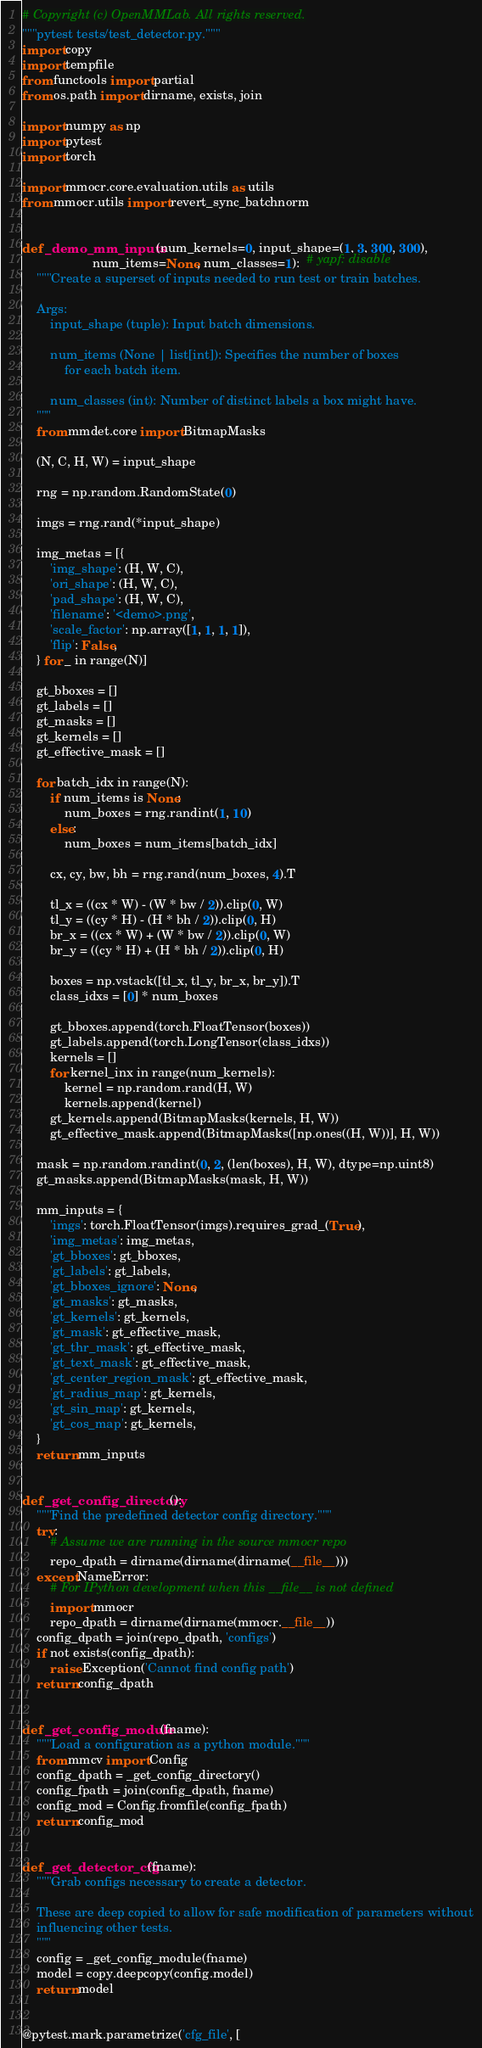Convert code to text. <code><loc_0><loc_0><loc_500><loc_500><_Python_># Copyright (c) OpenMMLab. All rights reserved.
"""pytest tests/test_detector.py."""
import copy
import tempfile
from functools import partial
from os.path import dirname, exists, join

import numpy as np
import pytest
import torch

import mmocr.core.evaluation.utils as utils
from mmocr.utils import revert_sync_batchnorm


def _demo_mm_inputs(num_kernels=0, input_shape=(1, 3, 300, 300),
                    num_items=None, num_classes=1):  # yapf: disable
    """Create a superset of inputs needed to run test or train batches.

    Args:
        input_shape (tuple): Input batch dimensions.

        num_items (None | list[int]): Specifies the number of boxes
            for each batch item.

        num_classes (int): Number of distinct labels a box might have.
    """
    from mmdet.core import BitmapMasks

    (N, C, H, W) = input_shape

    rng = np.random.RandomState(0)

    imgs = rng.rand(*input_shape)

    img_metas = [{
        'img_shape': (H, W, C),
        'ori_shape': (H, W, C),
        'pad_shape': (H, W, C),
        'filename': '<demo>.png',
        'scale_factor': np.array([1, 1, 1, 1]),
        'flip': False,
    } for _ in range(N)]

    gt_bboxes = []
    gt_labels = []
    gt_masks = []
    gt_kernels = []
    gt_effective_mask = []

    for batch_idx in range(N):
        if num_items is None:
            num_boxes = rng.randint(1, 10)
        else:
            num_boxes = num_items[batch_idx]

        cx, cy, bw, bh = rng.rand(num_boxes, 4).T

        tl_x = ((cx * W) - (W * bw / 2)).clip(0, W)
        tl_y = ((cy * H) - (H * bh / 2)).clip(0, H)
        br_x = ((cx * W) + (W * bw / 2)).clip(0, W)
        br_y = ((cy * H) + (H * bh / 2)).clip(0, H)

        boxes = np.vstack([tl_x, tl_y, br_x, br_y]).T
        class_idxs = [0] * num_boxes

        gt_bboxes.append(torch.FloatTensor(boxes))
        gt_labels.append(torch.LongTensor(class_idxs))
        kernels = []
        for kernel_inx in range(num_kernels):
            kernel = np.random.rand(H, W)
            kernels.append(kernel)
        gt_kernels.append(BitmapMasks(kernels, H, W))
        gt_effective_mask.append(BitmapMasks([np.ones((H, W))], H, W))

    mask = np.random.randint(0, 2, (len(boxes), H, W), dtype=np.uint8)
    gt_masks.append(BitmapMasks(mask, H, W))

    mm_inputs = {
        'imgs': torch.FloatTensor(imgs).requires_grad_(True),
        'img_metas': img_metas,
        'gt_bboxes': gt_bboxes,
        'gt_labels': gt_labels,
        'gt_bboxes_ignore': None,
        'gt_masks': gt_masks,
        'gt_kernels': gt_kernels,
        'gt_mask': gt_effective_mask,
        'gt_thr_mask': gt_effective_mask,
        'gt_text_mask': gt_effective_mask,
        'gt_center_region_mask': gt_effective_mask,
        'gt_radius_map': gt_kernels,
        'gt_sin_map': gt_kernels,
        'gt_cos_map': gt_kernels,
    }
    return mm_inputs


def _get_config_directory():
    """Find the predefined detector config directory."""
    try:
        # Assume we are running in the source mmocr repo
        repo_dpath = dirname(dirname(dirname(__file__)))
    except NameError:
        # For IPython development when this __file__ is not defined
        import mmocr
        repo_dpath = dirname(dirname(mmocr.__file__))
    config_dpath = join(repo_dpath, 'configs')
    if not exists(config_dpath):
        raise Exception('Cannot find config path')
    return config_dpath


def _get_config_module(fname):
    """Load a configuration as a python module."""
    from mmcv import Config
    config_dpath = _get_config_directory()
    config_fpath = join(config_dpath, fname)
    config_mod = Config.fromfile(config_fpath)
    return config_mod


def _get_detector_cfg(fname):
    """Grab configs necessary to create a detector.

    These are deep copied to allow for safe modification of parameters without
    influencing other tests.
    """
    config = _get_config_module(fname)
    model = copy.deepcopy(config.model)
    return model


@pytest.mark.parametrize('cfg_file', [</code> 